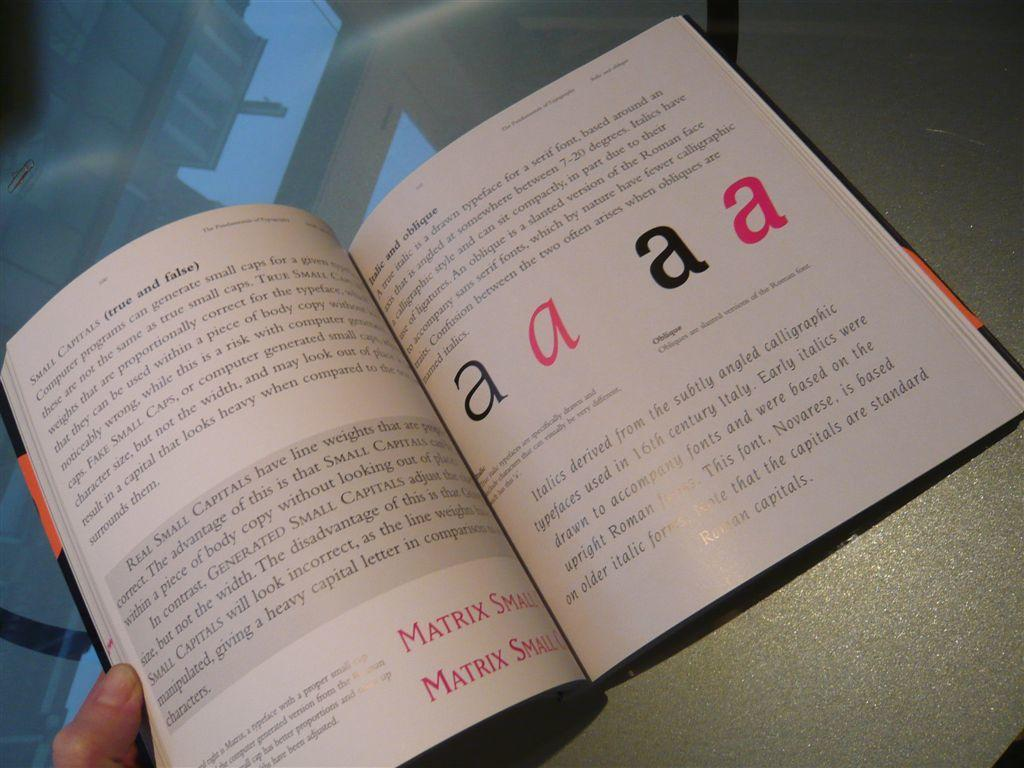Provide a one-sentence caption for the provided image. An open book is open to a page with the letter A written on it  four times. 